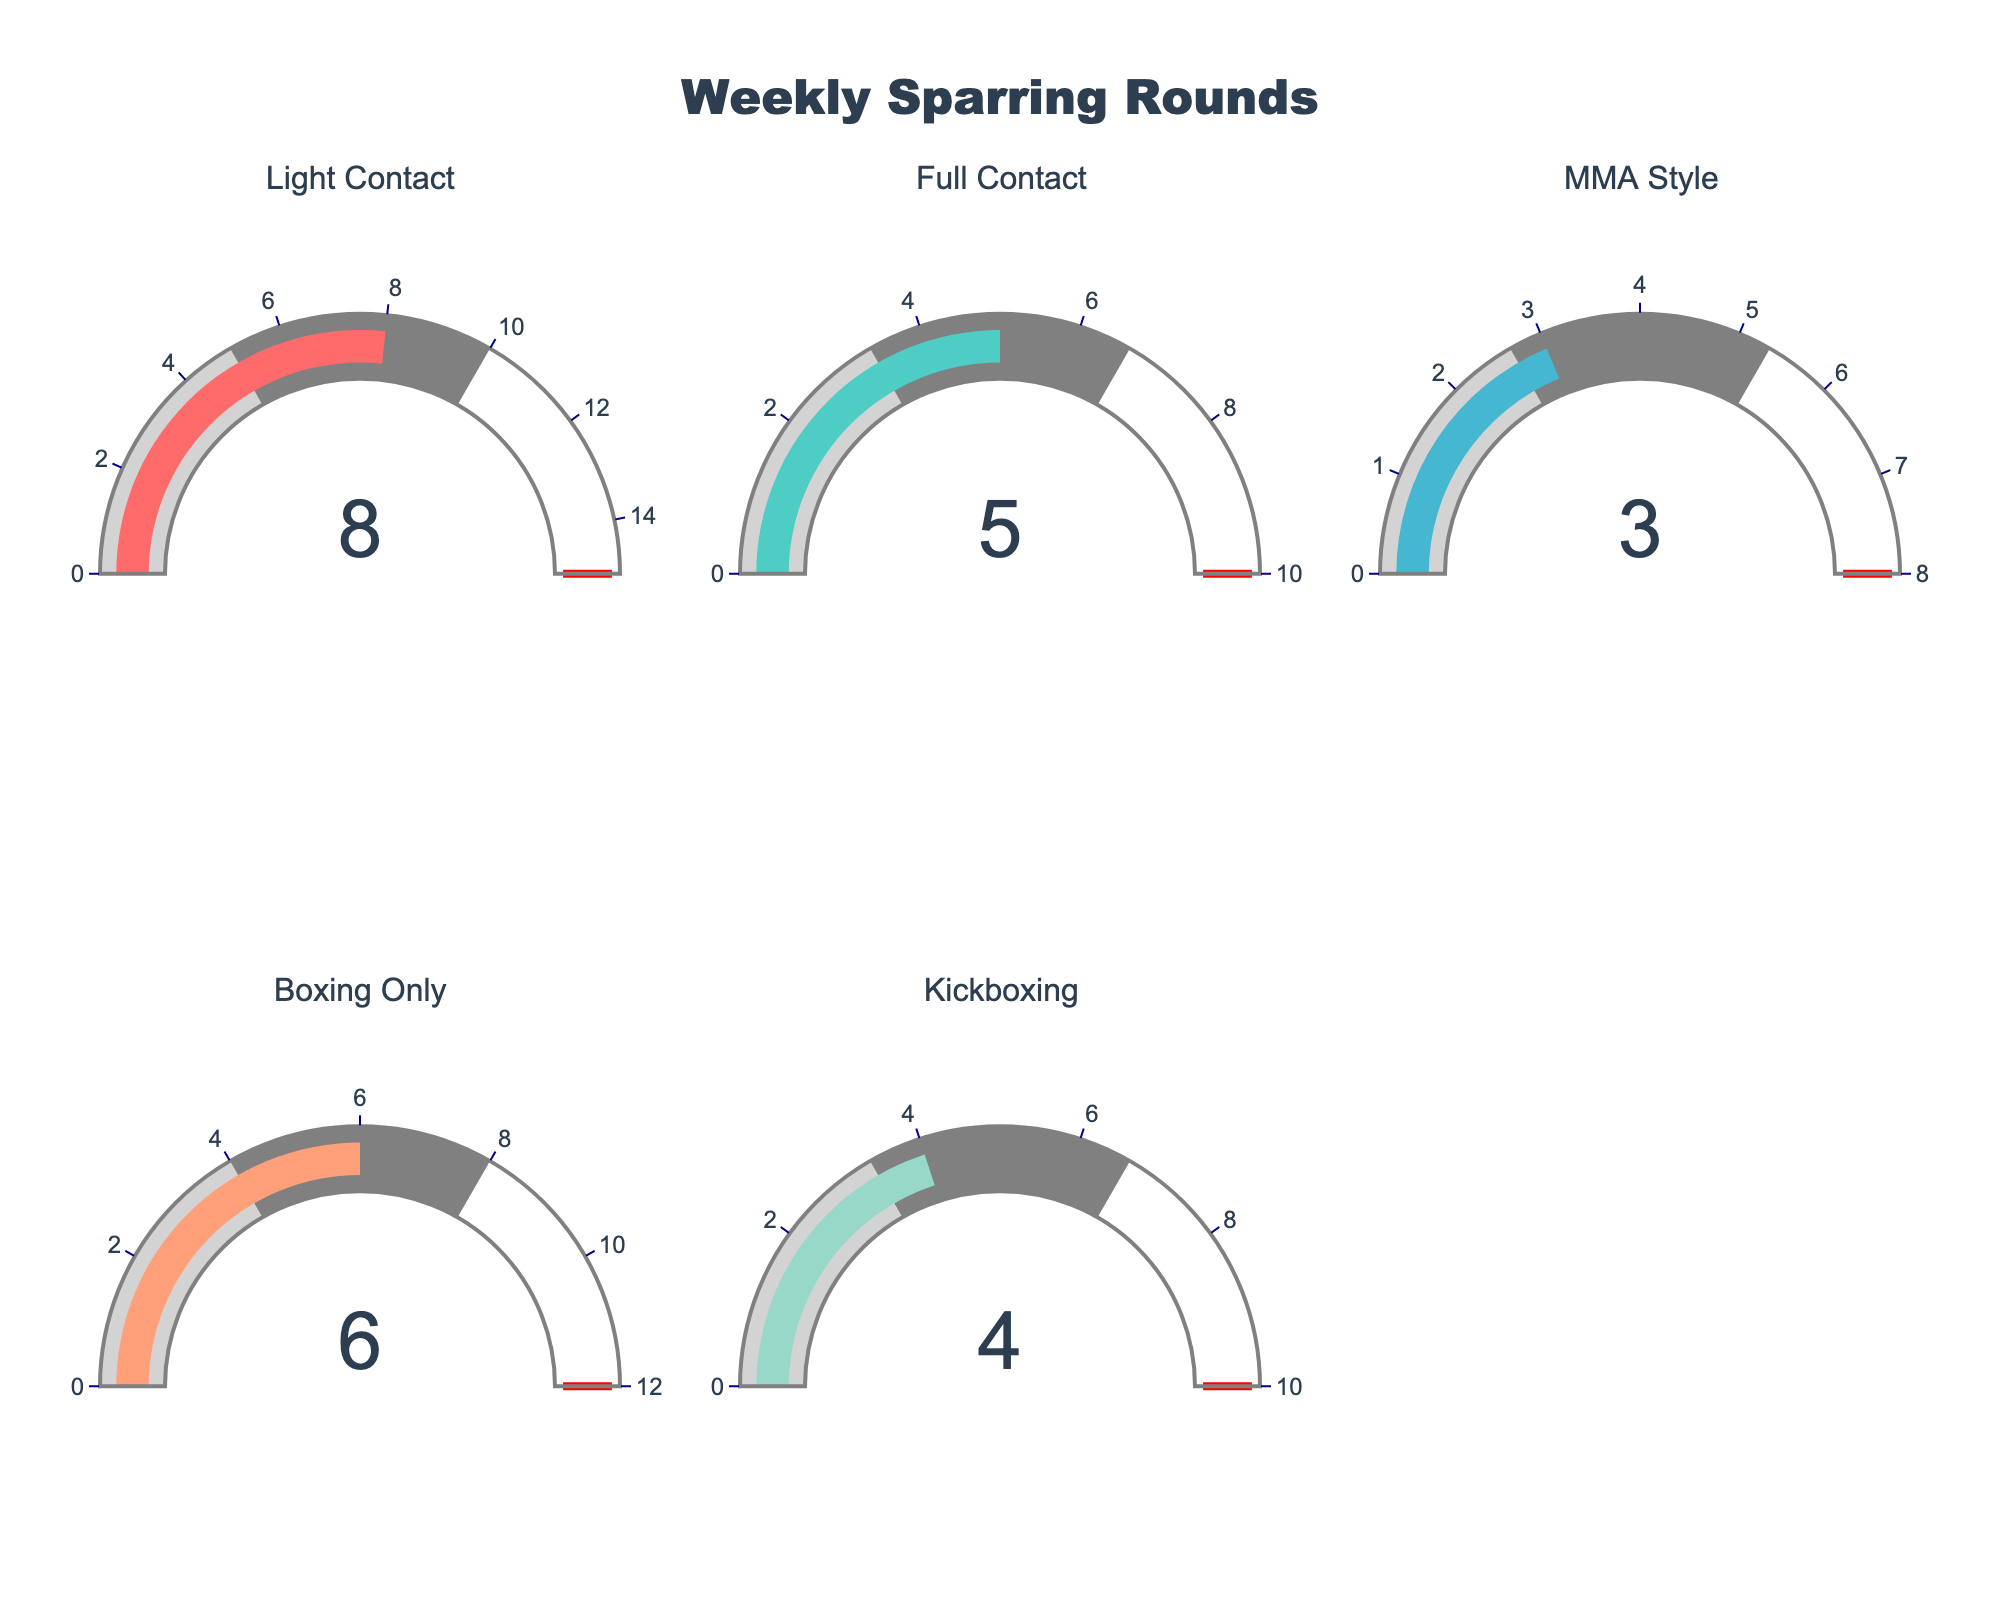What's the title of the figure? The title of the figure is displayed prominently at the top.
Answer: Weekly Sparring Rounds Which type of sparring has the highest number of completed rounds? By looking at the values displayed on each gauge, 8 is the highest number.
Answer: Light Contact Of the sparring types listed, which has the lowest maximum threshold? The maximum threshold values are indicated on the outer edge of the gauges. The lowest maximum value among them is 8.
Answer: MMA Style What is the difference between the rounds completed for Full Contact and Kickboxing? The Full Contact gauge shows 5 rounds and the Kickboxing gauge shows 4 rounds. The difference between these two numbers is 1.
Answer: 1 For which sparring type does the current value occupy exactly half of the maximum value? By comparing the current values to their maximum values on each gauge, the Full Contact type, with a current value of 5 and a maximum value of 10, fits this condition.
Answer: Full Contact What is the sum of the current rounds completed for Light Contact and Boxing Only? Adding the current rounds for Light Contact (8) and Boxing Only (6), the total is 14.
Answer: 14 Which sparring types have the same number of current rounds completed? By looking at the values displayed on each gauge, none of the sparring types have the same current number of rounds completed.
Answer: None If the threshold for each gauge is maxed out, how many total rounds would that represent across all sparring types? Sum the maximum values given for each sparring type: 15 + 10 + 8 + 12 + 10 = 55.
Answer: 55 What percentage of the maximum rounds is completed for Kickboxing? The gauge for Kickboxing has a maximum of 10 rounds. The current value is 4. To find the percentage, (4/10) * 100 = 40%.
Answer: 40% How many rounds are needed to reach the maximum for MMA Style sparring? The MMA Style gauge shows a current value of 3 rounds and a maximum of 8 rounds. Therefore, 8 - 3 = 5 rounds are needed to reach the maximum.
Answer: 5 